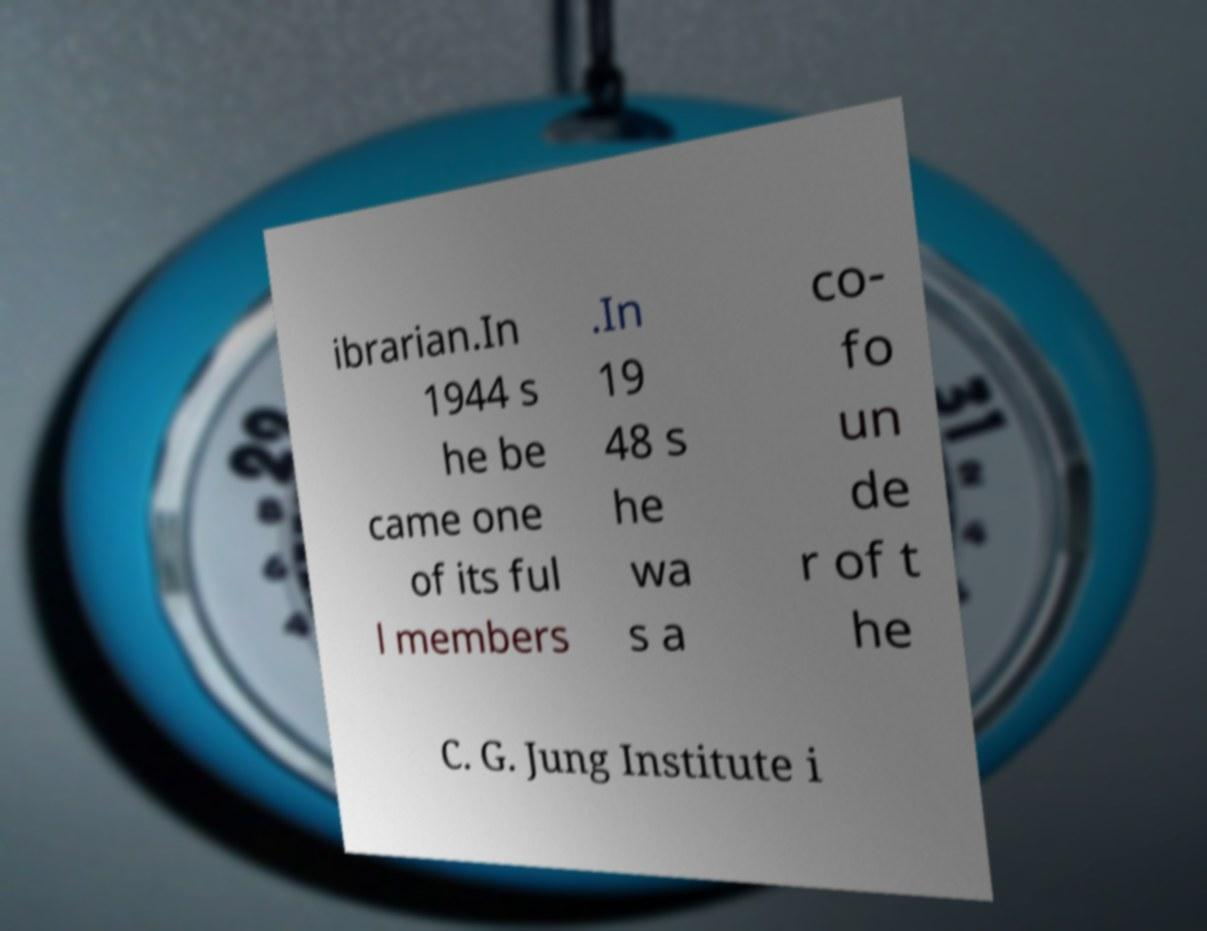I need the written content from this picture converted into text. Can you do that? ibrarian.In 1944 s he be came one of its ful l members .In 19 48 s he wa s a co- fo un de r of t he C. G. Jung Institute i 